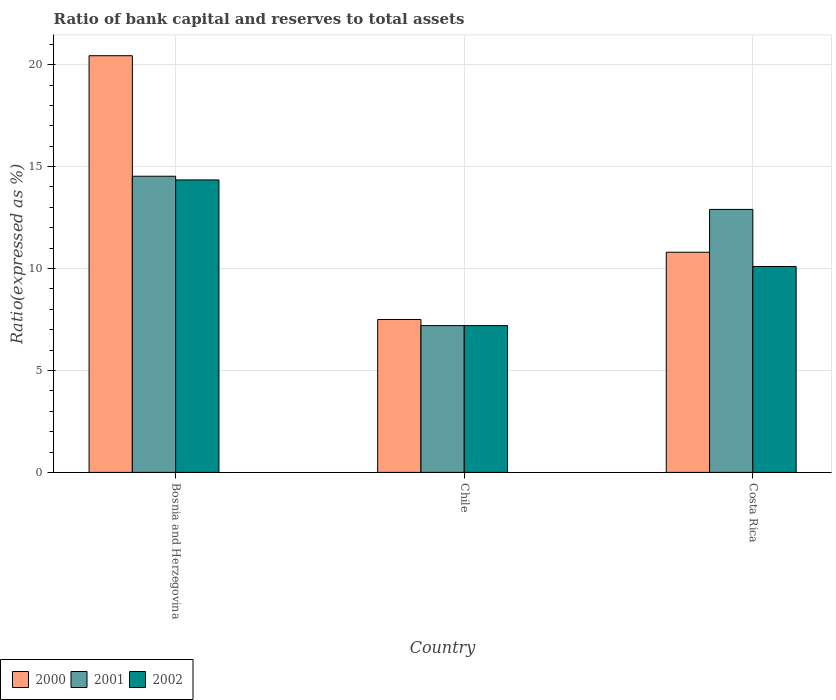How many groups of bars are there?
Give a very brief answer. 3. Are the number of bars on each tick of the X-axis equal?
Ensure brevity in your answer.  Yes. How many bars are there on the 1st tick from the left?
Your answer should be compact. 3. How many bars are there on the 3rd tick from the right?
Your answer should be compact. 3. What is the label of the 2nd group of bars from the left?
Make the answer very short. Chile. What is the ratio of bank capital and reserves to total assets in 2001 in Chile?
Provide a succinct answer. 7.2. Across all countries, what is the maximum ratio of bank capital and reserves to total assets in 2002?
Offer a terse response. 14.35. Across all countries, what is the minimum ratio of bank capital and reserves to total assets in 2000?
Offer a terse response. 7.5. In which country was the ratio of bank capital and reserves to total assets in 2000 maximum?
Your response must be concise. Bosnia and Herzegovina. What is the total ratio of bank capital and reserves to total assets in 2001 in the graph?
Your response must be concise. 34.63. What is the difference between the ratio of bank capital and reserves to total assets in 2001 in Bosnia and Herzegovina and that in Costa Rica?
Keep it short and to the point. 1.63. What is the difference between the ratio of bank capital and reserves to total assets in 2002 in Chile and the ratio of bank capital and reserves to total assets in 2000 in Costa Rica?
Provide a short and direct response. -3.6. What is the average ratio of bank capital and reserves to total assets in 2000 per country?
Make the answer very short. 12.91. What is the difference between the ratio of bank capital and reserves to total assets of/in 2000 and ratio of bank capital and reserves to total assets of/in 2002 in Chile?
Ensure brevity in your answer.  0.3. In how many countries, is the ratio of bank capital and reserves to total assets in 2002 greater than 20 %?
Your response must be concise. 0. What is the ratio of the ratio of bank capital and reserves to total assets in 2002 in Bosnia and Herzegovina to that in Chile?
Provide a short and direct response. 1.99. Is the ratio of bank capital and reserves to total assets in 2002 in Bosnia and Herzegovina less than that in Costa Rica?
Offer a terse response. No. Is the difference between the ratio of bank capital and reserves to total assets in 2000 in Bosnia and Herzegovina and Costa Rica greater than the difference between the ratio of bank capital and reserves to total assets in 2002 in Bosnia and Herzegovina and Costa Rica?
Your response must be concise. Yes. What is the difference between the highest and the second highest ratio of bank capital and reserves to total assets in 2000?
Offer a very short reply. -9.64. What is the difference between the highest and the lowest ratio of bank capital and reserves to total assets in 2002?
Provide a short and direct response. 7.15. In how many countries, is the ratio of bank capital and reserves to total assets in 2001 greater than the average ratio of bank capital and reserves to total assets in 2001 taken over all countries?
Ensure brevity in your answer.  2. Is it the case that in every country, the sum of the ratio of bank capital and reserves to total assets in 2000 and ratio of bank capital and reserves to total assets in 2002 is greater than the ratio of bank capital and reserves to total assets in 2001?
Your answer should be very brief. Yes. How many bars are there?
Give a very brief answer. 9. Are all the bars in the graph horizontal?
Offer a very short reply. No. How many countries are there in the graph?
Your response must be concise. 3. What is the difference between two consecutive major ticks on the Y-axis?
Give a very brief answer. 5. Are the values on the major ticks of Y-axis written in scientific E-notation?
Your answer should be compact. No. Does the graph contain grids?
Give a very brief answer. Yes. Where does the legend appear in the graph?
Ensure brevity in your answer.  Bottom left. How are the legend labels stacked?
Your response must be concise. Horizontal. What is the title of the graph?
Provide a succinct answer. Ratio of bank capital and reserves to total assets. What is the label or title of the X-axis?
Give a very brief answer. Country. What is the label or title of the Y-axis?
Your answer should be very brief. Ratio(expressed as %). What is the Ratio(expressed as %) in 2000 in Bosnia and Herzegovina?
Offer a very short reply. 20.44. What is the Ratio(expressed as %) of 2001 in Bosnia and Herzegovina?
Give a very brief answer. 14.53. What is the Ratio(expressed as %) in 2002 in Bosnia and Herzegovina?
Offer a very short reply. 14.35. What is the Ratio(expressed as %) of 2000 in Chile?
Keep it short and to the point. 7.5. What is the Ratio(expressed as %) of 2001 in Chile?
Offer a very short reply. 7.2. What is the Ratio(expressed as %) in 2000 in Costa Rica?
Your answer should be compact. 10.8. Across all countries, what is the maximum Ratio(expressed as %) in 2000?
Your answer should be compact. 20.44. Across all countries, what is the maximum Ratio(expressed as %) in 2001?
Keep it short and to the point. 14.53. Across all countries, what is the maximum Ratio(expressed as %) in 2002?
Your response must be concise. 14.35. Across all countries, what is the minimum Ratio(expressed as %) in 2001?
Provide a short and direct response. 7.2. What is the total Ratio(expressed as %) of 2000 in the graph?
Make the answer very short. 38.74. What is the total Ratio(expressed as %) in 2001 in the graph?
Make the answer very short. 34.63. What is the total Ratio(expressed as %) in 2002 in the graph?
Ensure brevity in your answer.  31.65. What is the difference between the Ratio(expressed as %) in 2000 in Bosnia and Herzegovina and that in Chile?
Your answer should be very brief. 12.94. What is the difference between the Ratio(expressed as %) in 2001 in Bosnia and Herzegovina and that in Chile?
Give a very brief answer. 7.33. What is the difference between the Ratio(expressed as %) in 2002 in Bosnia and Herzegovina and that in Chile?
Keep it short and to the point. 7.15. What is the difference between the Ratio(expressed as %) of 2000 in Bosnia and Herzegovina and that in Costa Rica?
Offer a terse response. 9.64. What is the difference between the Ratio(expressed as %) of 2001 in Bosnia and Herzegovina and that in Costa Rica?
Keep it short and to the point. 1.63. What is the difference between the Ratio(expressed as %) of 2002 in Bosnia and Herzegovina and that in Costa Rica?
Your answer should be very brief. 4.25. What is the difference between the Ratio(expressed as %) in 2000 in Bosnia and Herzegovina and the Ratio(expressed as %) in 2001 in Chile?
Ensure brevity in your answer.  13.24. What is the difference between the Ratio(expressed as %) of 2000 in Bosnia and Herzegovina and the Ratio(expressed as %) of 2002 in Chile?
Give a very brief answer. 13.24. What is the difference between the Ratio(expressed as %) in 2001 in Bosnia and Herzegovina and the Ratio(expressed as %) in 2002 in Chile?
Your response must be concise. 7.33. What is the difference between the Ratio(expressed as %) in 2000 in Bosnia and Herzegovina and the Ratio(expressed as %) in 2001 in Costa Rica?
Offer a very short reply. 7.54. What is the difference between the Ratio(expressed as %) in 2000 in Bosnia and Herzegovina and the Ratio(expressed as %) in 2002 in Costa Rica?
Give a very brief answer. 10.34. What is the difference between the Ratio(expressed as %) of 2001 in Bosnia and Herzegovina and the Ratio(expressed as %) of 2002 in Costa Rica?
Ensure brevity in your answer.  4.43. What is the difference between the Ratio(expressed as %) of 2000 in Chile and the Ratio(expressed as %) of 2001 in Costa Rica?
Provide a succinct answer. -5.4. What is the difference between the Ratio(expressed as %) of 2000 in Chile and the Ratio(expressed as %) of 2002 in Costa Rica?
Offer a very short reply. -2.6. What is the average Ratio(expressed as %) of 2000 per country?
Keep it short and to the point. 12.91. What is the average Ratio(expressed as %) in 2001 per country?
Make the answer very short. 11.54. What is the average Ratio(expressed as %) in 2002 per country?
Provide a short and direct response. 10.55. What is the difference between the Ratio(expressed as %) in 2000 and Ratio(expressed as %) in 2001 in Bosnia and Herzegovina?
Your answer should be compact. 5.91. What is the difference between the Ratio(expressed as %) in 2000 and Ratio(expressed as %) in 2002 in Bosnia and Herzegovina?
Ensure brevity in your answer.  6.09. What is the difference between the Ratio(expressed as %) in 2001 and Ratio(expressed as %) in 2002 in Bosnia and Herzegovina?
Provide a short and direct response. 0.18. What is the difference between the Ratio(expressed as %) of 2000 and Ratio(expressed as %) of 2001 in Costa Rica?
Your response must be concise. -2.1. What is the difference between the Ratio(expressed as %) in 2001 and Ratio(expressed as %) in 2002 in Costa Rica?
Offer a terse response. 2.8. What is the ratio of the Ratio(expressed as %) in 2000 in Bosnia and Herzegovina to that in Chile?
Provide a succinct answer. 2.73. What is the ratio of the Ratio(expressed as %) of 2001 in Bosnia and Herzegovina to that in Chile?
Make the answer very short. 2.02. What is the ratio of the Ratio(expressed as %) in 2002 in Bosnia and Herzegovina to that in Chile?
Provide a short and direct response. 1.99. What is the ratio of the Ratio(expressed as %) of 2000 in Bosnia and Herzegovina to that in Costa Rica?
Your response must be concise. 1.89. What is the ratio of the Ratio(expressed as %) in 2001 in Bosnia and Herzegovina to that in Costa Rica?
Provide a short and direct response. 1.13. What is the ratio of the Ratio(expressed as %) in 2002 in Bosnia and Herzegovina to that in Costa Rica?
Provide a short and direct response. 1.42. What is the ratio of the Ratio(expressed as %) in 2000 in Chile to that in Costa Rica?
Ensure brevity in your answer.  0.69. What is the ratio of the Ratio(expressed as %) of 2001 in Chile to that in Costa Rica?
Your response must be concise. 0.56. What is the ratio of the Ratio(expressed as %) of 2002 in Chile to that in Costa Rica?
Your answer should be very brief. 0.71. What is the difference between the highest and the second highest Ratio(expressed as %) of 2000?
Provide a succinct answer. 9.64. What is the difference between the highest and the second highest Ratio(expressed as %) in 2001?
Your answer should be compact. 1.63. What is the difference between the highest and the second highest Ratio(expressed as %) of 2002?
Ensure brevity in your answer.  4.25. What is the difference between the highest and the lowest Ratio(expressed as %) of 2000?
Ensure brevity in your answer.  12.94. What is the difference between the highest and the lowest Ratio(expressed as %) of 2001?
Your answer should be very brief. 7.33. What is the difference between the highest and the lowest Ratio(expressed as %) of 2002?
Your response must be concise. 7.15. 